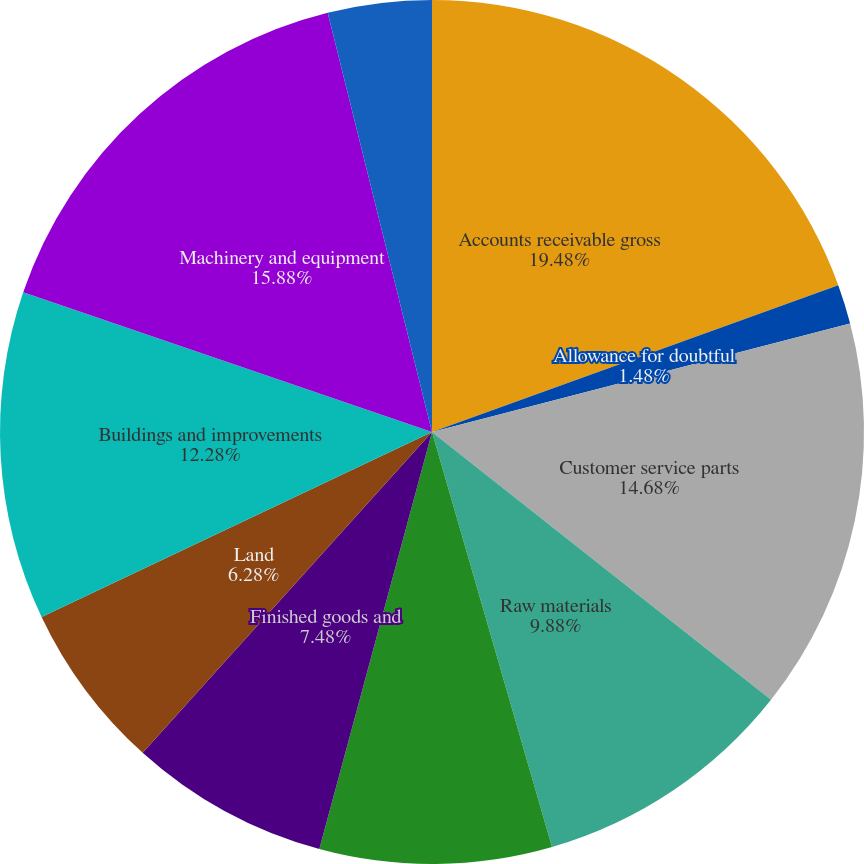<chart> <loc_0><loc_0><loc_500><loc_500><pie_chart><fcel>Accounts receivable gross<fcel>Allowance for doubtful<fcel>Customer service parts<fcel>Raw materials<fcel>Work-in-process<fcel>Finished goods and<fcel>Land<fcel>Buildings and improvements<fcel>Machinery and equipment<fcel>Office furniture and fixtures<nl><fcel>19.48%<fcel>1.48%<fcel>14.68%<fcel>9.88%<fcel>8.68%<fcel>7.48%<fcel>6.28%<fcel>12.28%<fcel>15.88%<fcel>3.88%<nl></chart> 